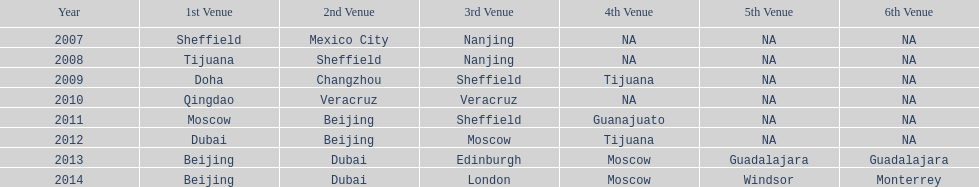Which year is previous to 2011 2010. Write the full table. {'header': ['Year', '1st Venue', '2nd Venue', '3rd Venue', '4th Venue', '5th Venue', '6th Venue'], 'rows': [['2007', 'Sheffield', 'Mexico City', 'Nanjing', 'NA', 'NA', 'NA'], ['2008', 'Tijuana', 'Sheffield', 'Nanjing', 'NA', 'NA', 'NA'], ['2009', 'Doha', 'Changzhou', 'Sheffield', 'Tijuana', 'NA', 'NA'], ['2010', 'Qingdao', 'Veracruz', 'Veracruz', 'NA', 'NA', 'NA'], ['2011', 'Moscow', 'Beijing', 'Sheffield', 'Guanajuato', 'NA', 'NA'], ['2012', 'Dubai', 'Beijing', 'Moscow', 'Tijuana', 'NA', 'NA'], ['2013', 'Beijing', 'Dubai', 'Edinburgh', 'Moscow', 'Guadalajara', 'Guadalajara'], ['2014', 'Beijing', 'Dubai', 'London', 'Moscow', 'Windsor', 'Monterrey']]} 